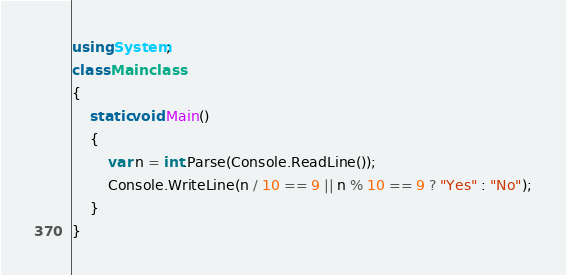<code> <loc_0><loc_0><loc_500><loc_500><_C#_>using System;
class Mainclass 
{
    static void Main()
    {
        var n = int.Parse(Console.ReadLine());
        Console.WriteLine(n / 10 == 9 || n % 10 == 9 ? "Yes" : "No");
    }
}</code> 